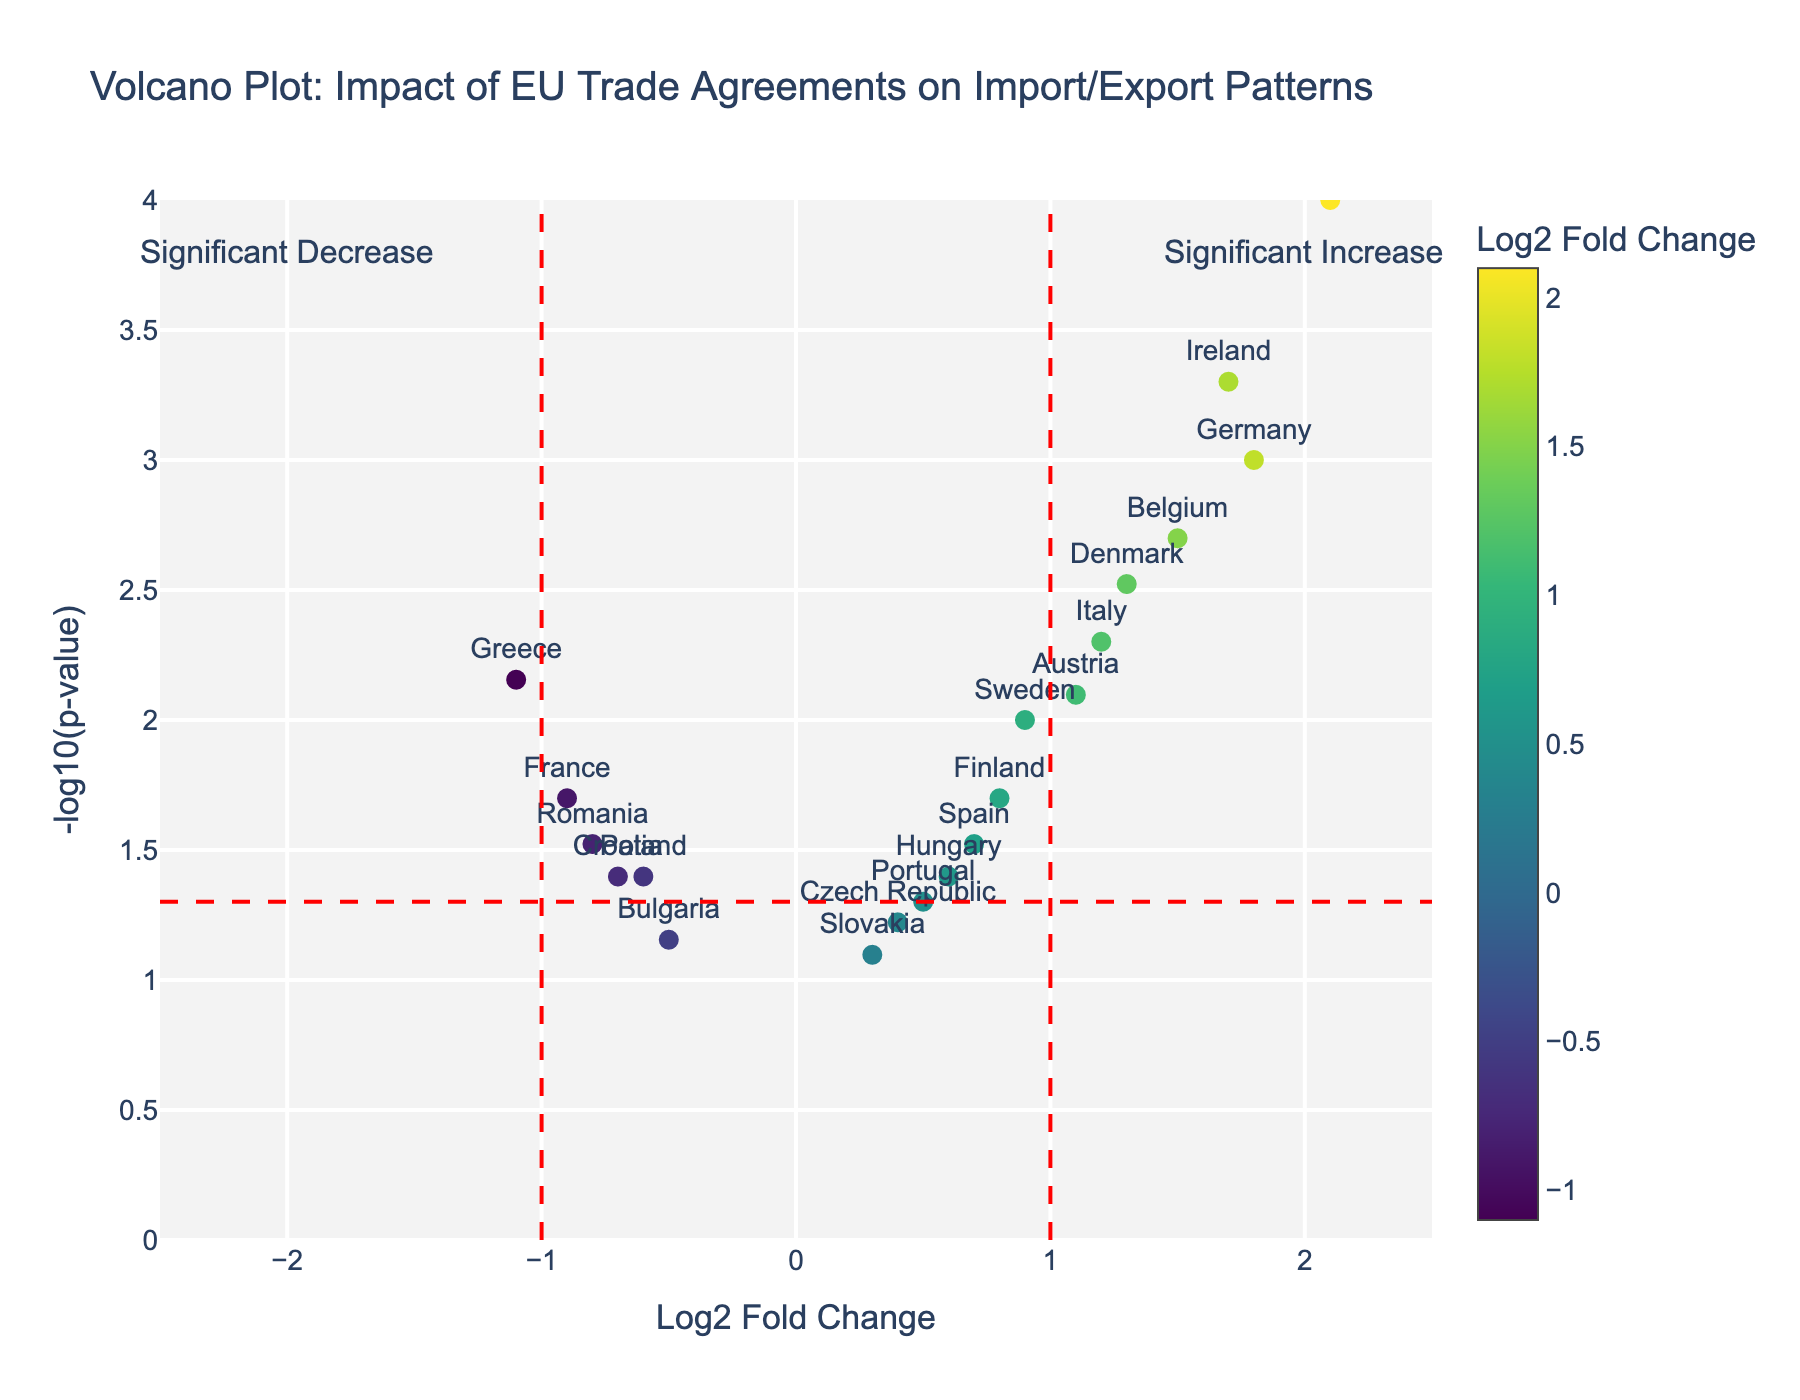What does the vertical axis represent? The vertical axis represents the -log10(p-value), which is a transformation of the p-value to emphasize significant changes. Lower p-values mean more significant changes and are shown higher on the plot.
Answer: -log10(p-value) What is the Log2 Fold Change for the Netherlands? To find the Log2 Fold Change for the Netherlands, locate the country label in the figure. The color of the marker as well as its position on the x-axis will indicate the Log2 Fold Change.
Answer: 2.1 Which country shows the most significant increase in import/export patterns? The country with the highest y-value (-log10(p-value)) and the largest positive x-value (Log2 Fold Change) indicates the most significant increase in import/export patterns. This is the Netherlands.
Answer: Netherlands How many countries have a Log2 Fold Change greater than 1? Count the number of data points to the right of the vertical line at Log2 Fold Change = 1. These represent countries with a Log2 Fold Change greater than 1.
Answer: 6 Which country has the least significant change in import/export patterns? The least significant change would be the country with the lowest y-value (-log10(p-value)). This is Bulgaria.
Answer: Bulgaria What is the Log2 Fold Change and p-value for Italy? Locate Italy on the plot. The Log2 Fold Change is found on the x-axis, and the p-value can be derived from the y-axis by transforming -log10(p-value) back to p-value. Italy is at Log2 Fold Change = 1.2 and -log10(p-value) = 2.3 approximately. The p-value is 0.005.
Answer: Log2FC: 1.2, p-value: 0.005 Compare Germany and Poland in terms of their import/export patterns change. Germany has a Log2 Fold Change of 1.8, suggesting a stronger positive change, while Poland has a Log2 Fold Change of -0.6, indicating a negative change. Additionally, Germany has a lower p-value than Poland, thus the change is more significant for Germany.
Answer: Germany has a more significant positive change What is the total number of countries showing a significant decrease in import/export patterns? Significant decreases are indicated by data points to the left of the vertical line at Log2 Fold Change = -1. Count these points.
Answer: 1 (Greece) Is there any country with a Log2 Fold Change near 0 but still significant? A significant criterion is a low p-value (higher position on y-axis). Check the values near Log2 Fold Change = 0 and identify if any meet the significance threshold line (horizontal red dashed line at -log10(p-value) ~1.3).
Answer: Hungary Which country has a p-value around 0.05? Look for a data point near the horizontal red dashed line at approximately -log10(p-value) = 1.3, which represents p-value ~0.05. The point closest to this line is Portugal.
Answer: Portugal 